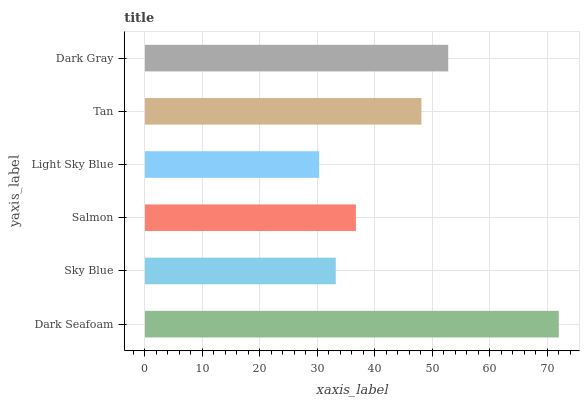Is Light Sky Blue the minimum?
Answer yes or no. Yes. Is Dark Seafoam the maximum?
Answer yes or no. Yes. Is Sky Blue the minimum?
Answer yes or no. No. Is Sky Blue the maximum?
Answer yes or no. No. Is Dark Seafoam greater than Sky Blue?
Answer yes or no. Yes. Is Sky Blue less than Dark Seafoam?
Answer yes or no. Yes. Is Sky Blue greater than Dark Seafoam?
Answer yes or no. No. Is Dark Seafoam less than Sky Blue?
Answer yes or no. No. Is Tan the high median?
Answer yes or no. Yes. Is Salmon the low median?
Answer yes or no. Yes. Is Dark Seafoam the high median?
Answer yes or no. No. Is Light Sky Blue the low median?
Answer yes or no. No. 